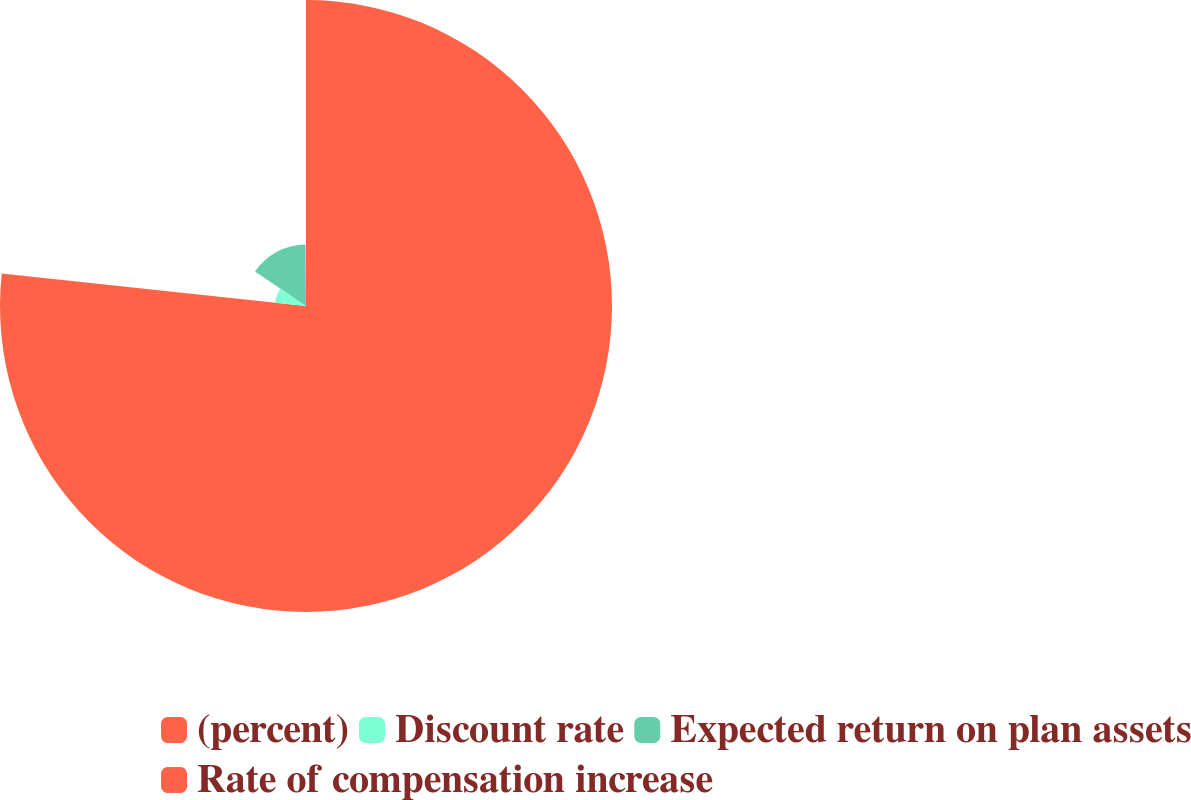Convert chart. <chart><loc_0><loc_0><loc_500><loc_500><pie_chart><fcel>(percent)<fcel>Discount rate<fcel>Expected return on plan assets<fcel>Rate of compensation increase<nl><fcel>76.7%<fcel>7.77%<fcel>15.43%<fcel>0.11%<nl></chart> 